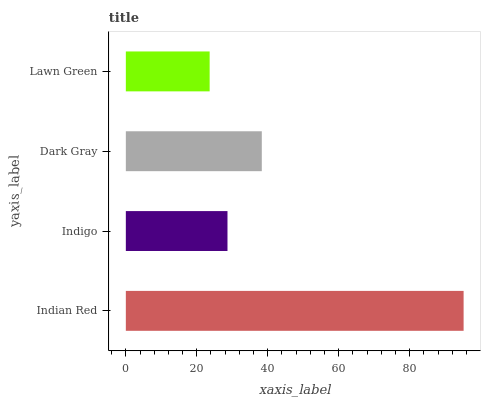Is Lawn Green the minimum?
Answer yes or no. Yes. Is Indian Red the maximum?
Answer yes or no. Yes. Is Indigo the minimum?
Answer yes or no. No. Is Indigo the maximum?
Answer yes or no. No. Is Indian Red greater than Indigo?
Answer yes or no. Yes. Is Indigo less than Indian Red?
Answer yes or no. Yes. Is Indigo greater than Indian Red?
Answer yes or no. No. Is Indian Red less than Indigo?
Answer yes or no. No. Is Dark Gray the high median?
Answer yes or no. Yes. Is Indigo the low median?
Answer yes or no. Yes. Is Indian Red the high median?
Answer yes or no. No. Is Indian Red the low median?
Answer yes or no. No. 